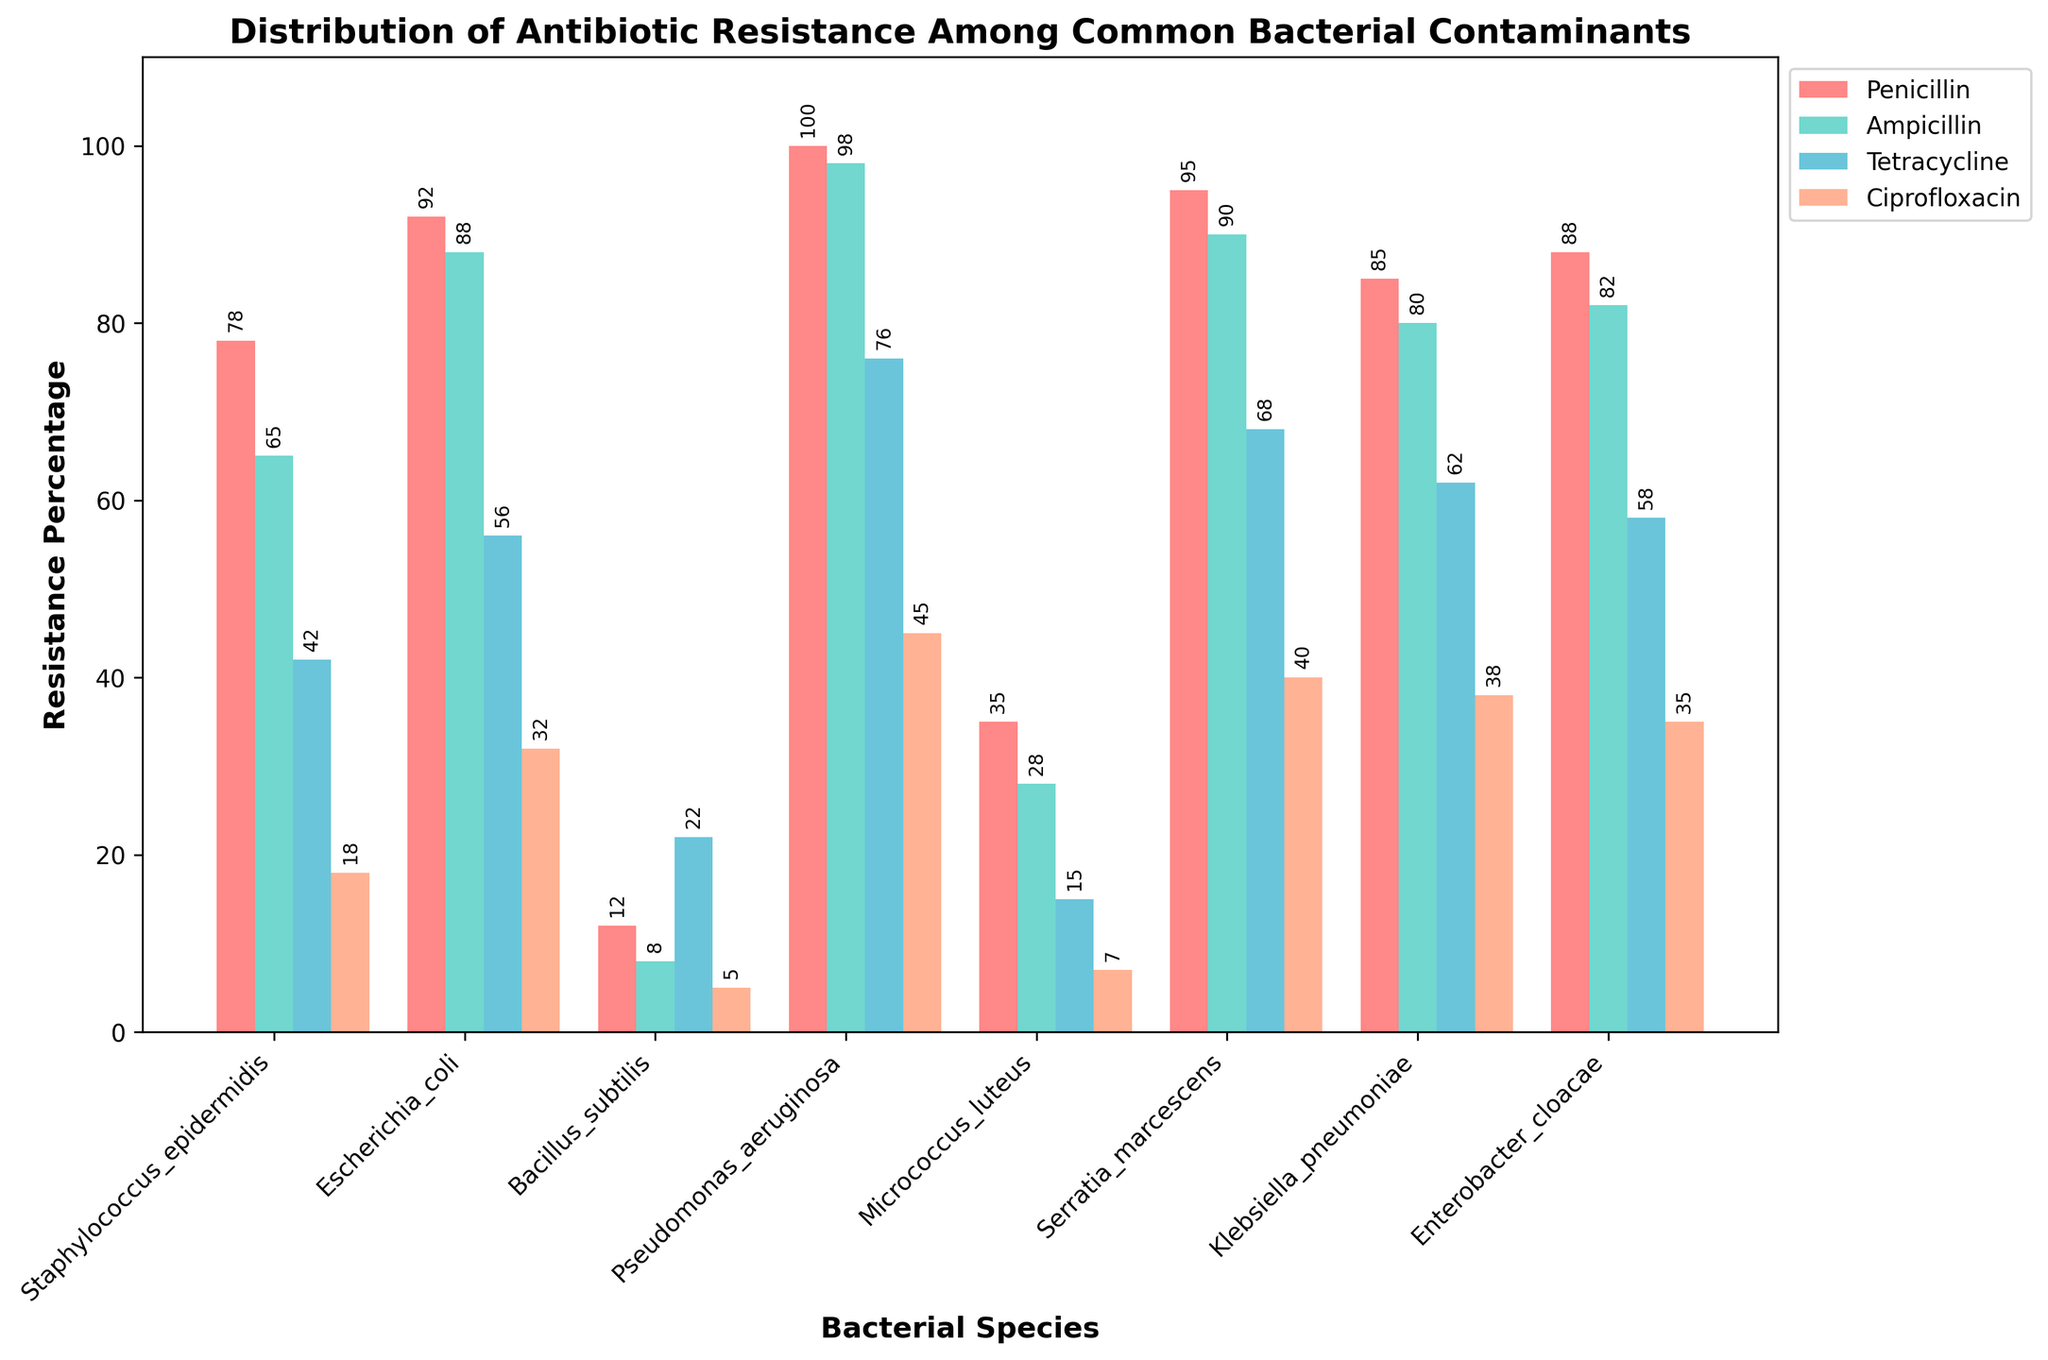Which bacterial species has the highest resistance to Ciprofloxacin? To find the bacterial species with the highest resistance to Ciprofloxacin, look for the tallest bar among the ones representing Ciprofloxacin resistance. The tallest Ciprofloxacin bar is for Pseudomonas aeruginosa.
Answer: Pseudomonas aeruginosa What is the average Penicillin resistance percentage among all bacterial species? To calculate the average, sum the Penicillin resistance percentages of all bacterial species and then divide by the total number of species. The percentages are 78, 92, 12, 100, 35, 95, 85, and 88. Sum = 585, and there are 8 species. The average is 585 / 8 = 73.125.
Answer: 73.125 Which bacterial species shows a higher resistance to Tetracycline than to Penicillin? Compare the Tetracycline resistance bar height with the Penicillin resistance bar height for each species. Bacillus subtilis has a higher percentage of resistance to Tetracycline (22) than Penicillin (12).
Answer: Bacillus subtilis Between Staphylococcus epidermidis and Klebsiella pneumoniae, which species has a higher resistance to Ampicillin? Look at the heights of the Ampicillin resistance bars for both species. Staphylococcus epidermidis has 65%, whereas Klebsiella pneumoniae has 80%.
Answer: Klebsiella pneumoniae What is the total resistance percentage for Enterobacter cloacae across all four antibiotics? Sum the resistance percentages for Enterobacter cloacae for all antibiotics: Penicillin (88), Ampicillin (82), Tetracycline (58), and Ciprofloxacin (35). Total = 88 + 82 + 58 + 35 = 263.
Answer: 263 Which bacterial species has the lowest resistance to Tetracycline? Identify the shortest bar among those representing Tetracycline resistance. The shortest bar is for Micrococcus luteus, with resistance of 15%.
Answer: Micrococcus luteus How much more resistant is Escherichia coli to Ampicillin compared to Penicillin? Subtract the Penicillin resistance percentage from the Ampicillin resistance percentage for Escherichia coli: 88 (Ampicillin) - 92 (Penicillin) = -4. Escherichia coli is 4% less resistant to Ampicillin compared to Penicillin.
Answer: -4 Among the listed species, which has mid-range resistance to all antibiotics? Look for a species whose bars across all antibiotics roughly fall in the middle range. Micrococcus luteus consistently shows mid-range values with resistance percentages of 35, 28, 15, and 7.
Answer: Micrococcus luteus What is the difference in Ciprofloxacin resistance between Pseudomonas aeruginosa and Enterobacter cloacae? Subtract the Ciprofloxacin resistance percentage of Enterobacter cloacae from that of Pseudomonas aeruginosa: 45% (Pseudomonas aeruginosa) - 35% (Enterobacter cloacae) = 10%.
Answer: 10 